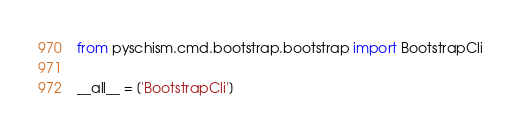Convert code to text. <code><loc_0><loc_0><loc_500><loc_500><_Python_>from pyschism.cmd.bootstrap.bootstrap import BootstrapCli

__all__ = ['BootstrapCli']
</code> 